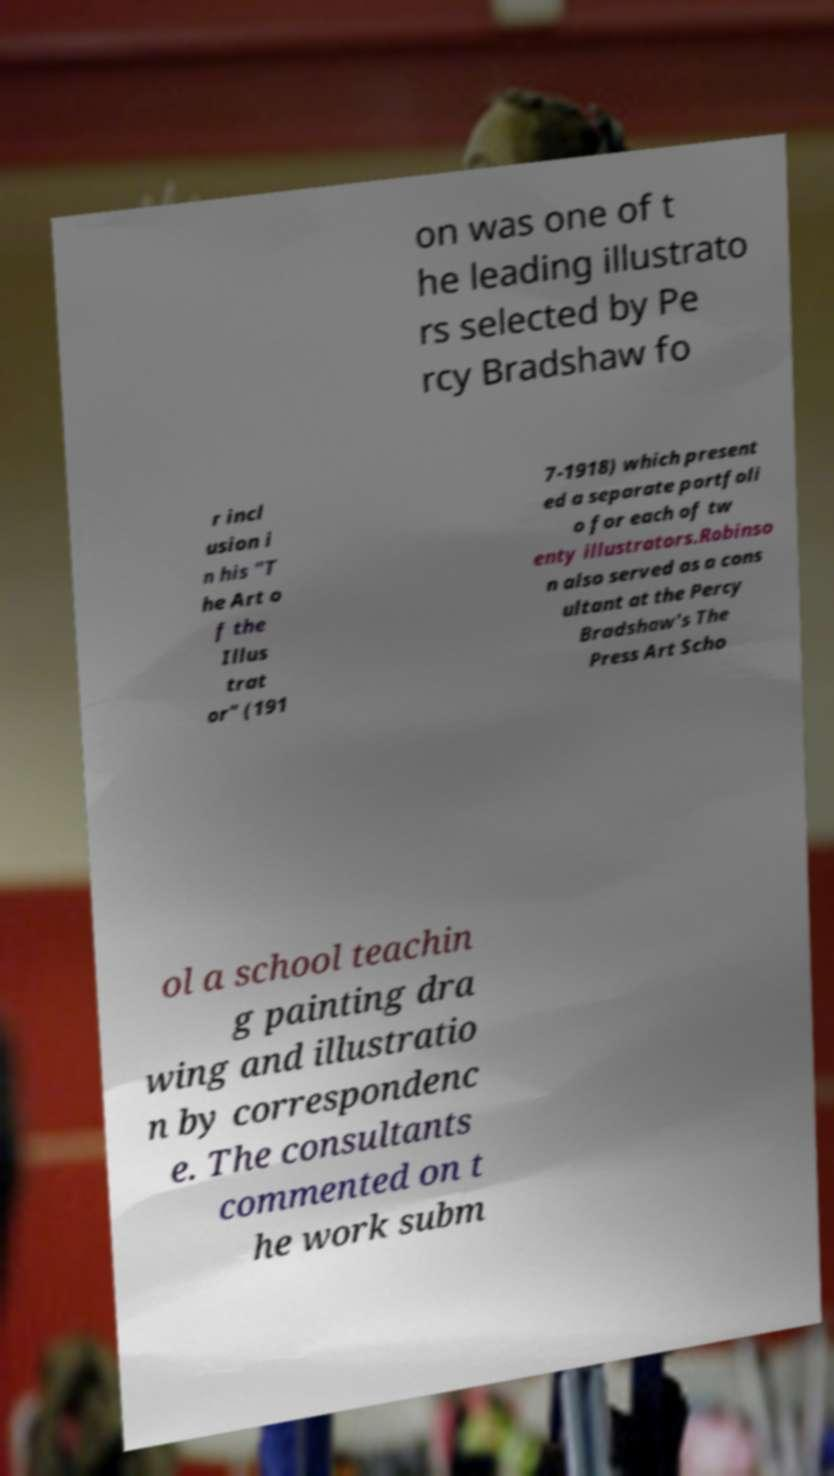Can you accurately transcribe the text from the provided image for me? on was one of t he leading illustrato rs selected by Pe rcy Bradshaw fo r incl usion i n his "T he Art o f the Illus trat or" (191 7-1918) which present ed a separate portfoli o for each of tw enty illustrators.Robinso n also served as a cons ultant at the Percy Bradshaw's The Press Art Scho ol a school teachin g painting dra wing and illustratio n by correspondenc e. The consultants commented on t he work subm 